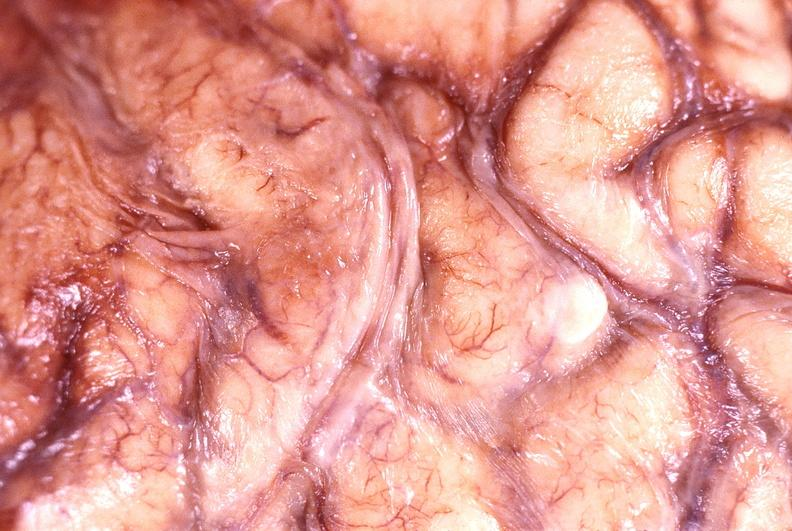does this image show brain abscess?
Answer the question using a single word or phrase. Yes 